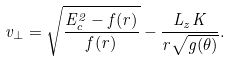<formula> <loc_0><loc_0><loc_500><loc_500>v _ { \perp } = \sqrt { { \frac { E _ { c } ^ { 2 } - f ( r ) } { f ( r ) } } } - { \frac { L _ { z } K } { r \sqrt { g ( \theta ) } } } .</formula> 